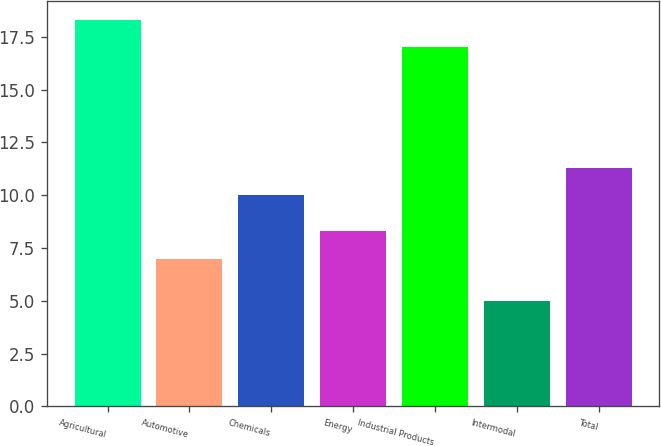Convert chart to OTSL. <chart><loc_0><loc_0><loc_500><loc_500><bar_chart><fcel>Agricultural<fcel>Automotive<fcel>Chemicals<fcel>Energy<fcel>Industrial Products<fcel>Intermodal<fcel>Total<nl><fcel>18.3<fcel>7<fcel>10<fcel>8.3<fcel>17<fcel>5<fcel>11.3<nl></chart> 